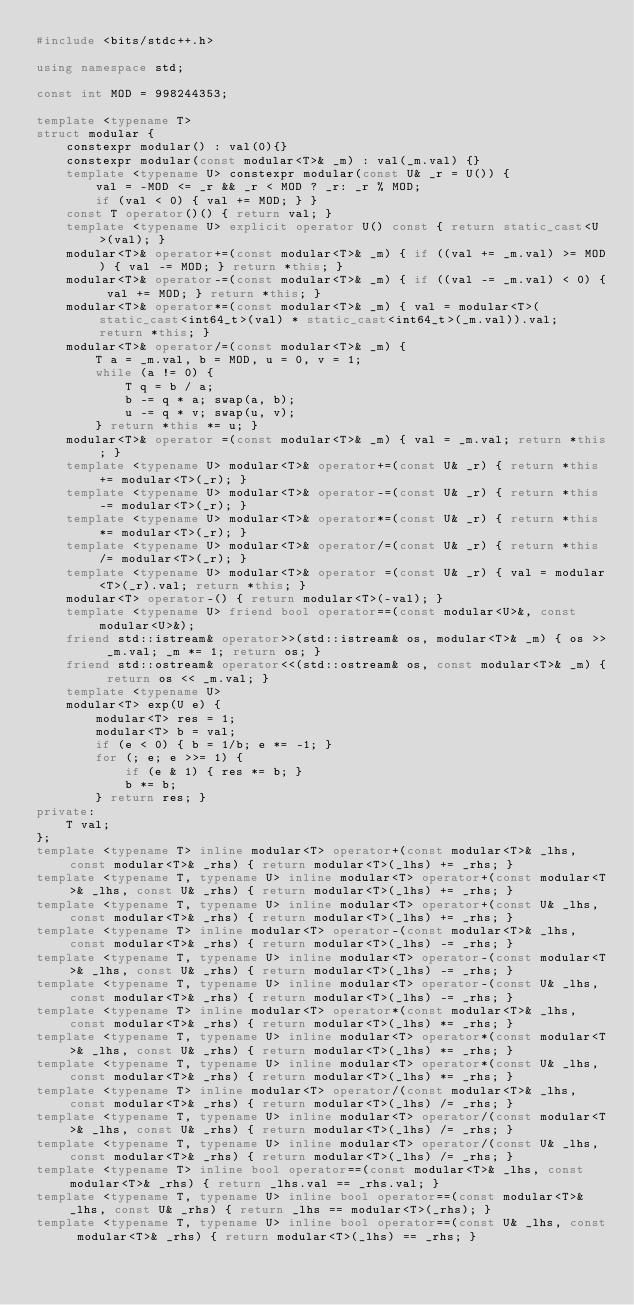Convert code to text. <code><loc_0><loc_0><loc_500><loc_500><_C++_>#include <bits/stdc++.h>

using namespace std;

const int MOD = 998244353;

template <typename T>
struct modular {
    constexpr modular() : val(0){}
    constexpr modular(const modular<T>& _m) : val(_m.val) {}
    template <typename U> constexpr modular(const U& _r = U()) {
        val = -MOD <= _r && _r < MOD ? _r: _r % MOD;
        if (val < 0) { val += MOD; } }
    const T operator()() { return val; }
    template <typename U> explicit operator U() const { return static_cast<U>(val); }
    modular<T>& operator+=(const modular<T>& _m) { if ((val += _m.val) >= MOD) { val -= MOD; } return *this; }
    modular<T>& operator-=(const modular<T>& _m) { if ((val -= _m.val) < 0) { val += MOD; } return *this; }
    modular<T>& operator*=(const modular<T>& _m) { val = modular<T>(static_cast<int64_t>(val) * static_cast<int64_t>(_m.val)).val; return *this; }
    modular<T>& operator/=(const modular<T>& _m) {
        T a = _m.val, b = MOD, u = 0, v = 1;
        while (a != 0) {
            T q = b / a;
            b -= q * a; swap(a, b);
            u -= q * v; swap(u, v); 
        } return *this *= u; }
    modular<T>& operator =(const modular<T>& _m) { val = _m.val; return *this; }
    template <typename U> modular<T>& operator+=(const U& _r) { return *this += modular<T>(_r); }
    template <typename U> modular<T>& operator-=(const U& _r) { return *this -= modular<T>(_r); }
    template <typename U> modular<T>& operator*=(const U& _r) { return *this *= modular<T>(_r); }
    template <typename U> modular<T>& operator/=(const U& _r) { return *this /= modular<T>(_r); } 
    template <typename U> modular<T>& operator =(const U& _r) { val = modular<T>(_r).val; return *this; }
    modular<T> operator-() { return modular<T>(-val); }    
    template <typename U> friend bool operator==(const modular<U>&, const modular<U>&);
    friend std::istream& operator>>(std::istream& os, modular<T>& _m) { os >> _m.val; _m *= 1; return os; }
    friend std::ostream& operator<<(std::ostream& os, const modular<T>& _m) { return os << _m.val; }
    template <typename U>
    modular<T> exp(U e) {
        modular<T> res = 1;
        modular<T> b = val;
        if (e < 0) { b = 1/b; e *= -1; }
        for (; e; e >>= 1) {
            if (e & 1) { res *= b; }
            b *= b;
        } return res; }
private:
    T val;
};
template <typename T> inline modular<T> operator+(const modular<T>& _lhs, const modular<T>& _rhs) { return modular<T>(_lhs) += _rhs; }
template <typename T, typename U> inline modular<T> operator+(const modular<T>& _lhs, const U& _rhs) { return modular<T>(_lhs) += _rhs; }
template <typename T, typename U> inline modular<T> operator+(const U& _lhs, const modular<T>& _rhs) { return modular<T>(_lhs) += _rhs; }
template <typename T> inline modular<T> operator-(const modular<T>& _lhs, const modular<T>& _rhs) { return modular<T>(_lhs) -= _rhs; }
template <typename T, typename U> inline modular<T> operator-(const modular<T>& _lhs, const U& _rhs) { return modular<T>(_lhs) -= _rhs; }
template <typename T, typename U> inline modular<T> operator-(const U& _lhs, const modular<T>& _rhs) { return modular<T>(_lhs) -= _rhs; }
template <typename T> inline modular<T> operator*(const modular<T>& _lhs, const modular<T>& _rhs) { return modular<T>(_lhs) *= _rhs; }
template <typename T, typename U> inline modular<T> operator*(const modular<T>& _lhs, const U& _rhs) { return modular<T>(_lhs) *= _rhs; }
template <typename T, typename U> inline modular<T> operator*(const U& _lhs, const modular<T>& _rhs) { return modular<T>(_lhs) *= _rhs; }
template <typename T> inline modular<T> operator/(const modular<T>& _lhs, const modular<T>& _rhs) { return modular<T>(_lhs) /= _rhs; }
template <typename T, typename U> inline modular<T> operator/(const modular<T>& _lhs, const U& _rhs) { return modular<T>(_lhs) /= _rhs; }
template <typename T, typename U> inline modular<T> operator/(const U& _lhs, const modular<T>& _rhs) { return modular<T>(_lhs) /= _rhs; }
template <typename T> inline bool operator==(const modular<T>& _lhs, const modular<T>& _rhs) { return _lhs.val == _rhs.val; }
template <typename T, typename U> inline bool operator==(const modular<T>& _lhs, const U& _rhs) { return _lhs == modular<T>(_rhs); }
template <typename T, typename U> inline bool operator==(const U& _lhs, const modular<T>& _rhs) { return modular<T>(_lhs) == _rhs; }</code> 